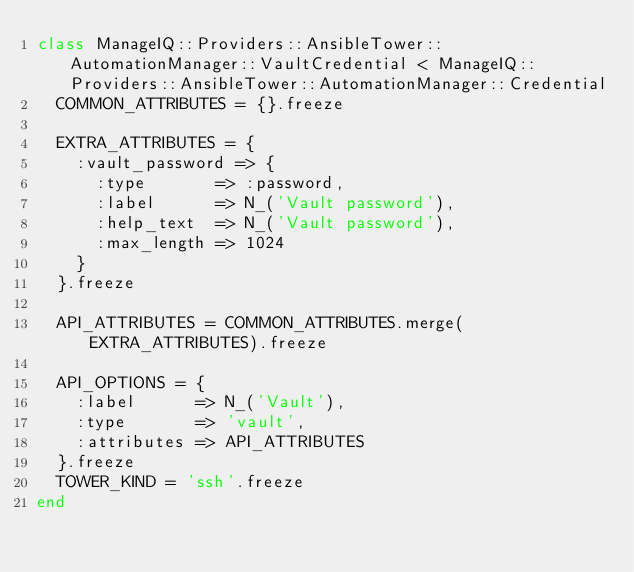Convert code to text. <code><loc_0><loc_0><loc_500><loc_500><_Ruby_>class ManageIQ::Providers::AnsibleTower::AutomationManager::VaultCredential < ManageIQ::Providers::AnsibleTower::AutomationManager::Credential
  COMMON_ATTRIBUTES = {}.freeze

  EXTRA_ATTRIBUTES = {
    :vault_password => {
      :type       => :password,
      :label      => N_('Vault password'),
      :help_text  => N_('Vault password'),
      :max_length => 1024
    }
  }.freeze

  API_ATTRIBUTES = COMMON_ATTRIBUTES.merge(EXTRA_ATTRIBUTES).freeze

  API_OPTIONS = {
    :label      => N_('Vault'),
    :type       => 'vault',
    :attributes => API_ATTRIBUTES
  }.freeze
  TOWER_KIND = 'ssh'.freeze
end
</code> 